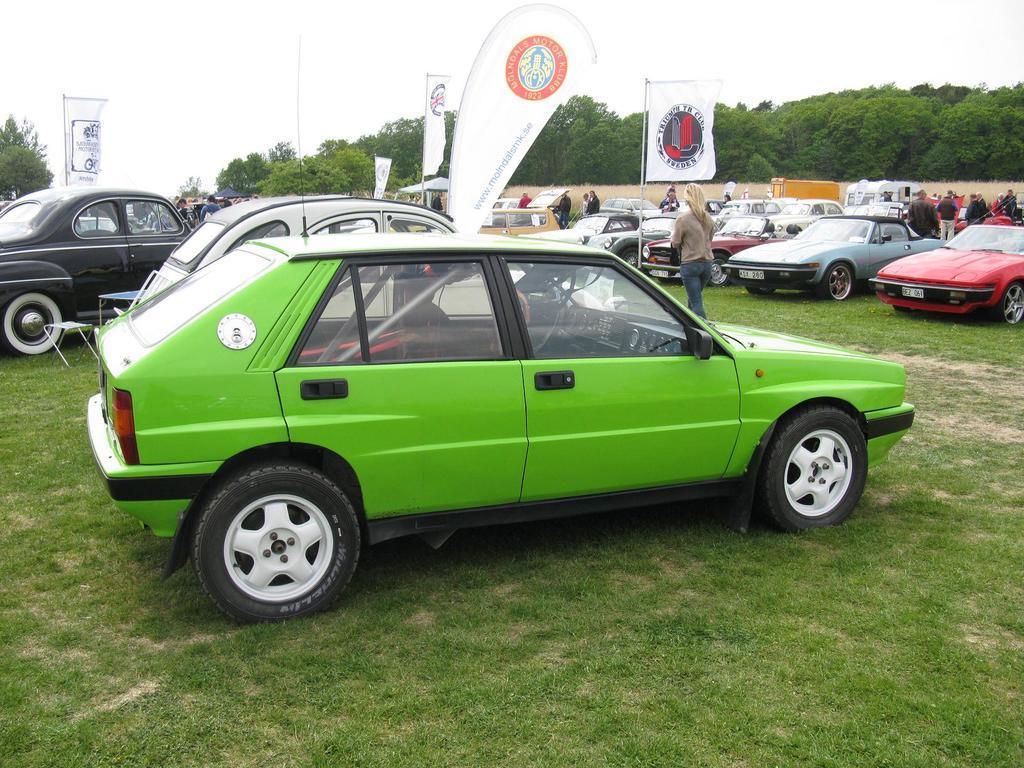Please provide a concise description of this image. In this image I see number of cars and I see number of people and I see few banners on which there are logos and I see the grass. In the background I see number of trees and I see the sky. 